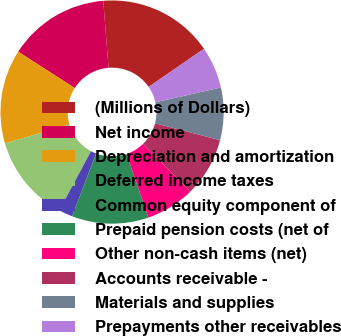Convert chart to OTSL. <chart><loc_0><loc_0><loc_500><loc_500><pie_chart><fcel>(Millions of Dollars)<fcel>Net income<fcel>Depreciation and amortization<fcel>Deferred income taxes<fcel>Common equity component of<fcel>Prepaid pension costs (net of<fcel>Other non-cash items (net)<fcel>Accounts receivable -<fcel>Materials and supplies<fcel>Prepayments other receivables<nl><fcel>16.66%<fcel>14.64%<fcel>13.63%<fcel>12.62%<fcel>2.02%<fcel>11.11%<fcel>7.07%<fcel>8.59%<fcel>7.58%<fcel>6.06%<nl></chart> 